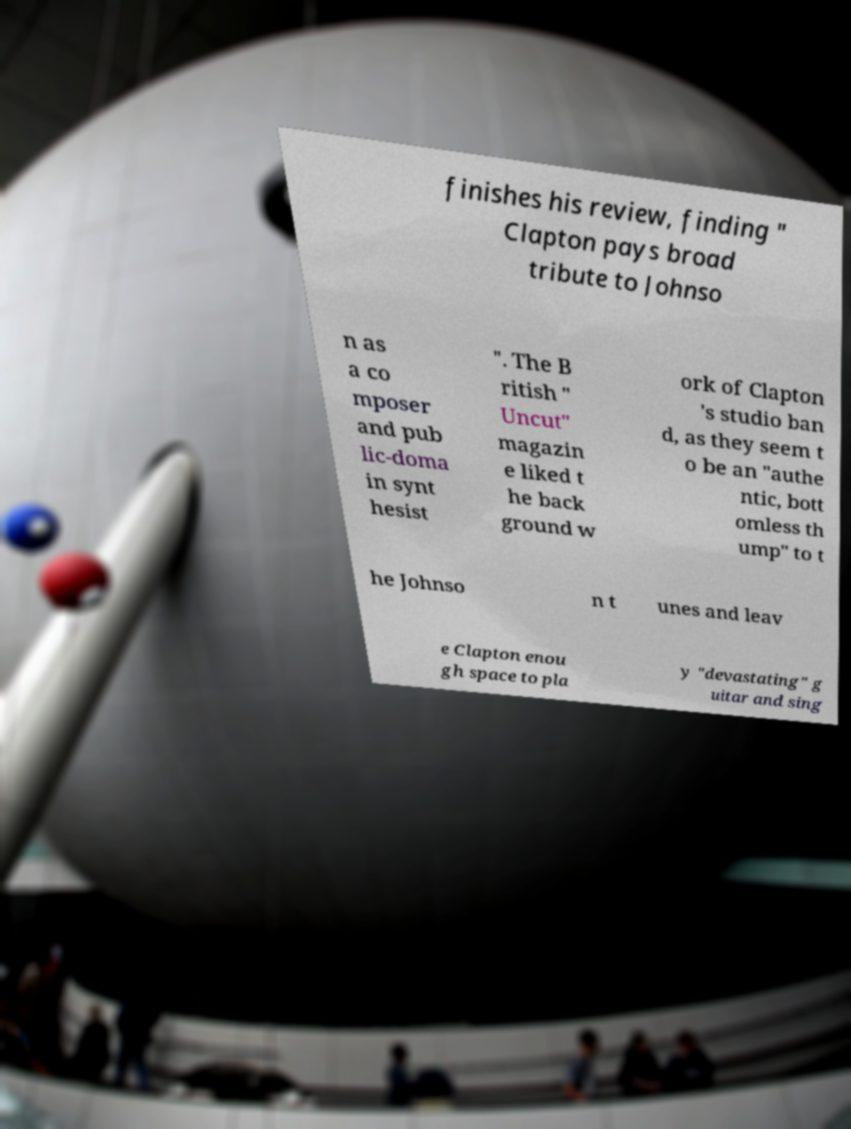What messages or text are displayed in this image? I need them in a readable, typed format. finishes his review, finding " Clapton pays broad tribute to Johnso n as a co mposer and pub lic-doma in synt hesist ". The B ritish " Uncut" magazin e liked t he back ground w ork of Clapton 's studio ban d, as they seem t o be an "authe ntic, bott omless th ump" to t he Johnso n t unes and leav e Clapton enou gh space to pla y "devastating" g uitar and sing 